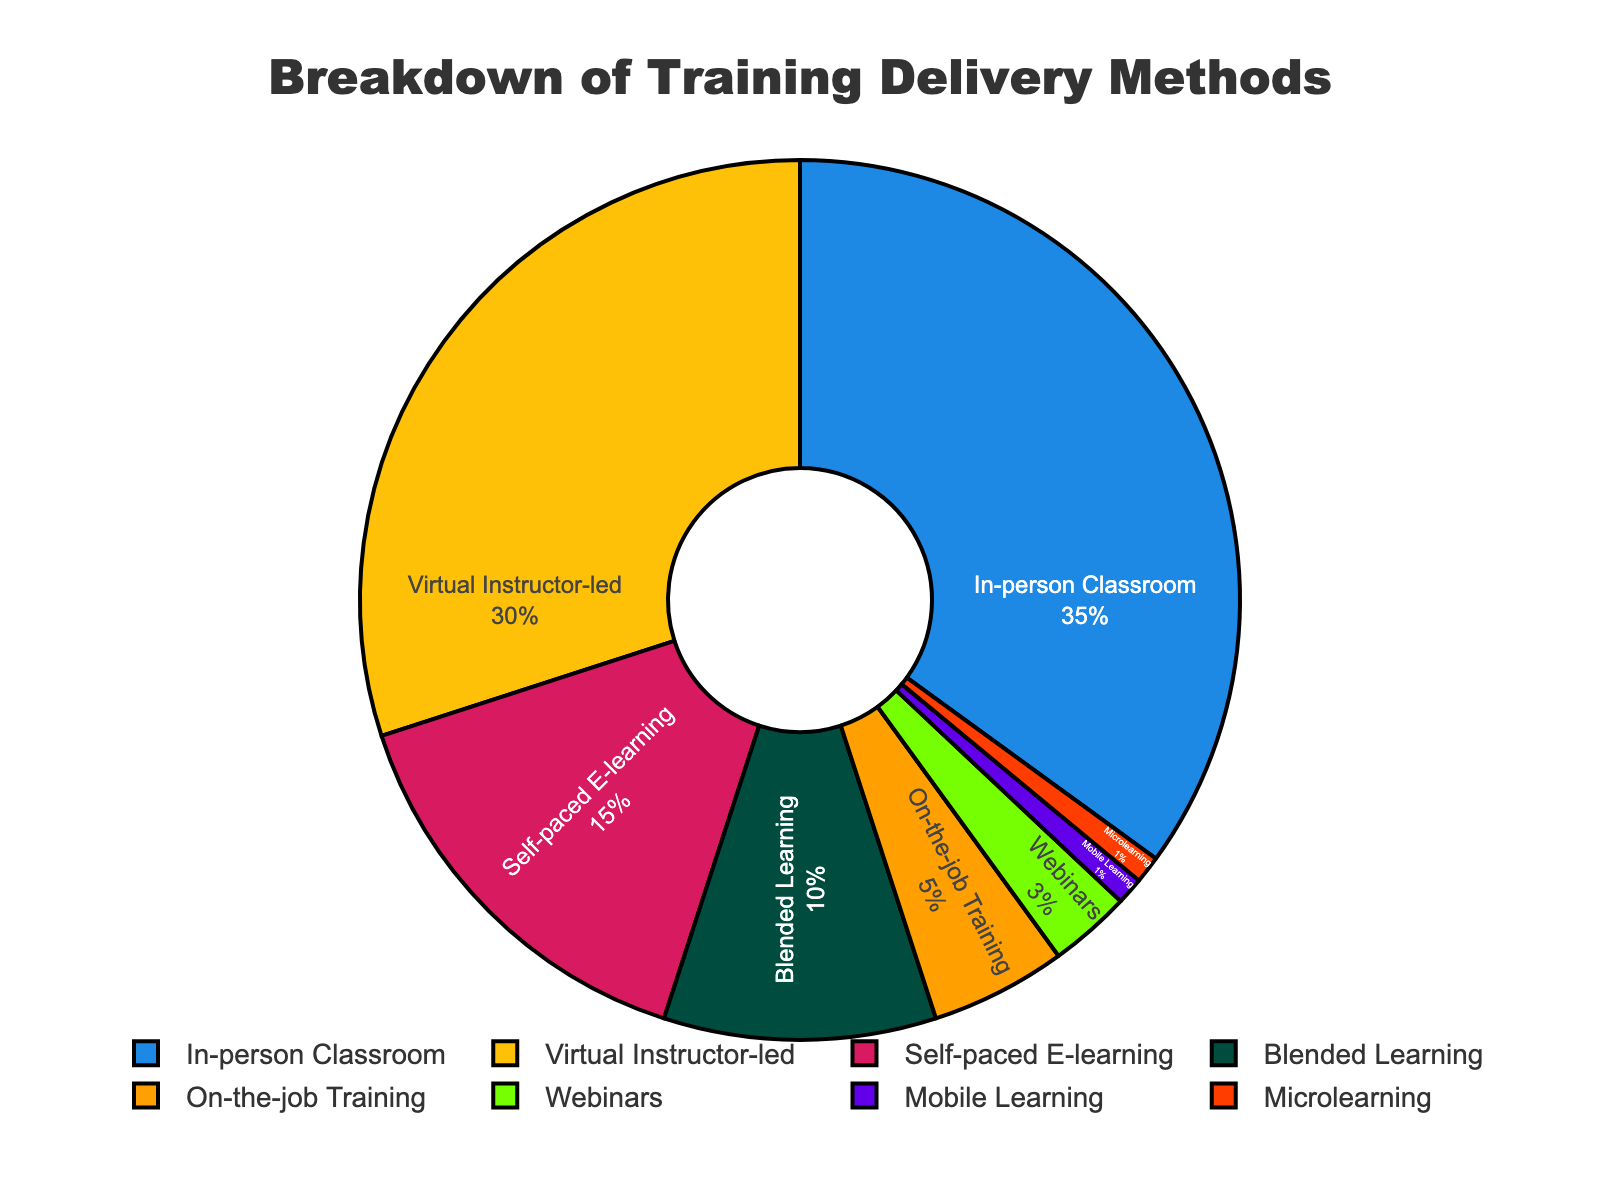What percentage of the training methods are delivered virtually? To find the percentage of virtual training methods, sum the percentages of "Virtual Instructor-led" and "Self-paced E-learning". "Virtual Instructor-led" is 30%, and "Self-paced E-learning" is 15%. Therefore, 30% + 15% = 45%.
Answer: 45% Which training method has the smallest percentage of delivery? By observing the breakdown of percentages, both "Mobile Learning" and "Microlearning" have the smallest percentage, each with 1%.
Answer: Mobile Learning and Microlearning What is the combined percentage of "In-person Classroom" and "Blended Learning" methods? Sum the percentages of "In-person Classroom" (35%) and "Blended Learning" (10%). Thus, 35% + 10% = 45%.
Answer: 45% Which two training methods together constitute the majority of the training delivery methods? Look for the largest percentages. "In-person Classroom" is 35% and "Virtual Instructor-led" is 30%. Together, 35% + 30% = 65%, which is more than 50%.
Answer: In-person Classroom and Virtual Instructor-led How many times larger is the percentage of "In-person Classroom" compared to "Webinars"? "In-person Classroom" is 35% and "Webinars" is 3%. To find how many times larger, divide 35% by 3%. Therefore, 35 / 3 ≈ 11.67 times.
Answer: Approximately 11.67 times Which training method occupies the largest segment and what percentage does it represent? The largest single segment in the pie chart represents the "In-person Classroom" with a percentage of 35%.
Answer: In-person Classroom, 35% Is the percentage of "Self-paced E-learning" training higher or lower than "Blended Learning"? Look at the chart, "Self-paced E-learning" is 15% and "Blended Learning" is 10%. Since 15% is greater than 10%, "Self-paced E-learning" is higher.
Answer: Higher What is the difference in percentage between "On-the-job Training" and "Webinars"? Subtract the smaller percentage from the larger one. "On-the-job Training" is 5% and "Webinars" is 3%. So, 5% - 3% = 2%.
Answer: 2% How much greater is the percentage of "Blended Learning" compared to "Mobile Learning"? "Blended Learning" is 10%, and "Mobile Learning" is 1%. To find the difference, subtract the smaller percentage from the larger one: 10% - 1% = 9%.
Answer: 9% What percentage of training methods make up less than 10% each? Identify the methods with percentages below 10%: "On-the-job Training" (5%), "Webinars" (3%), "Mobile Learning" (1%), and "Microlearning" (1%). Summing them gives 5% + 3% + 1% + 1% = 10%. Therefore, 10% of training methods are less than 10% each.
Answer: 10% 